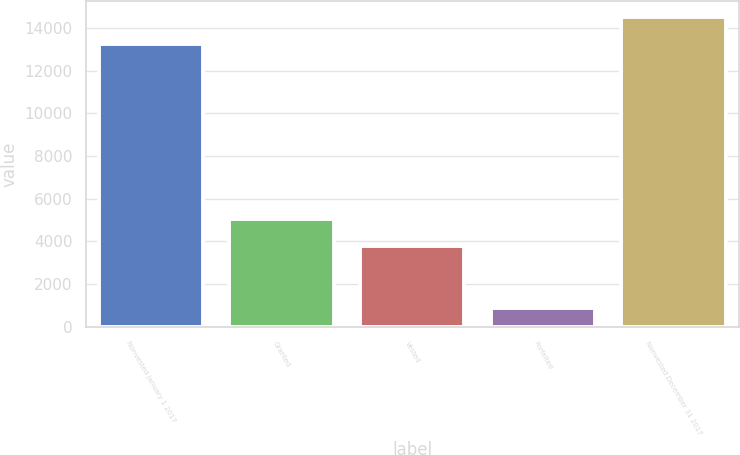Convert chart. <chart><loc_0><loc_0><loc_500><loc_500><bar_chart><fcel>Nonvested January 1 2017<fcel>Granted<fcel>Vested<fcel>Forfeited<fcel>Nonvested December 31 2017<nl><fcel>13266<fcel>5068.3<fcel>3795<fcel>876<fcel>14539.3<nl></chart> 